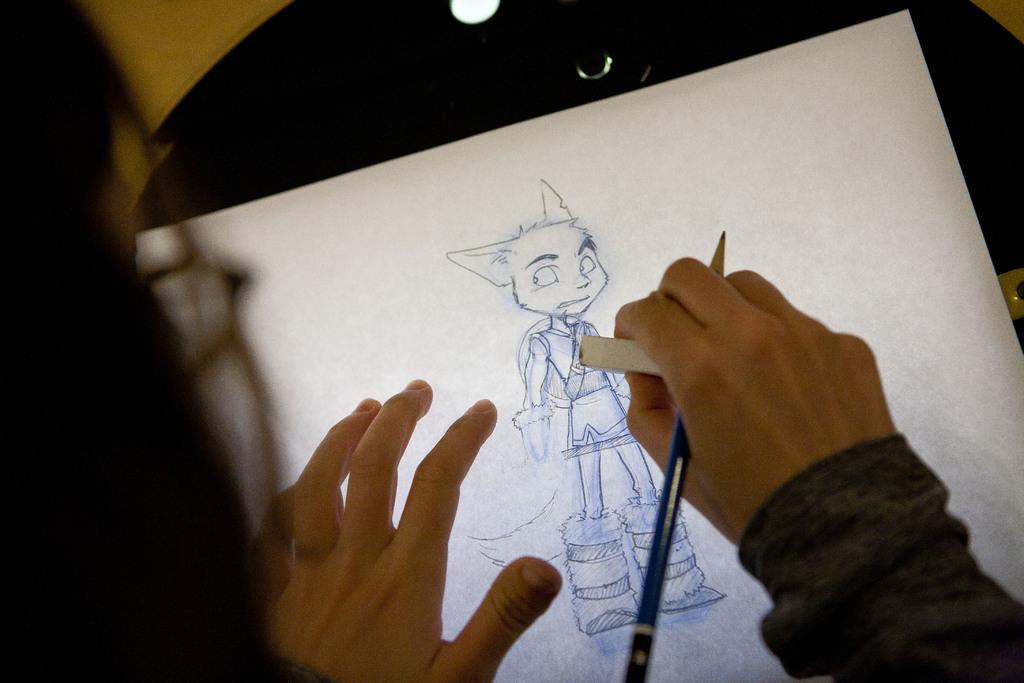What is the color of the object in the image? The object in the image is black. What is placed on the black object? A paper is on the black object. Can you describe the person in the image? The person is holding a pencil and an eraser. What is the person doing with the paper? The person is drawing on the paper. How many clams are visible on the black object in the image? There are no clams visible on the black object in the image. What type of tree is growing near the person in the image? There is no tree present in the image. 